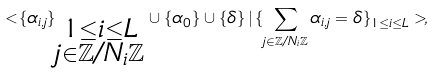<formula> <loc_0><loc_0><loc_500><loc_500>< \{ \alpha _ { i , j } \} _ { \substack { 1 \leq i \leq L \\ j \in \mathbb { Z } / N _ { i } \mathbb { Z } } } \cup \{ \alpha _ { 0 } \} \cup \{ \delta \} \, | \, \{ \sum _ { j \in \mathbb { Z } / N _ { i } \mathbb { Z } } \alpha _ { i , j } = \delta \} _ { 1 \leq i \leq L } > ,</formula> 